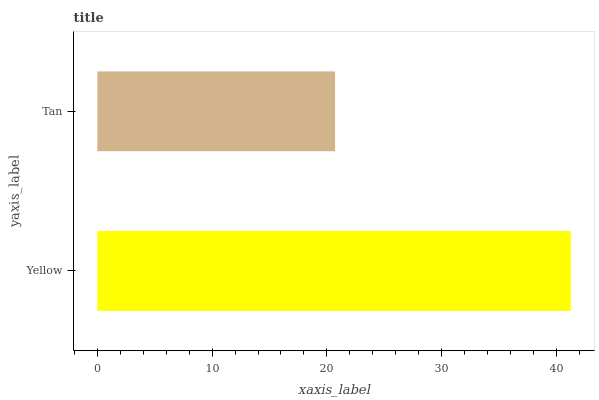Is Tan the minimum?
Answer yes or no. Yes. Is Yellow the maximum?
Answer yes or no. Yes. Is Tan the maximum?
Answer yes or no. No. Is Yellow greater than Tan?
Answer yes or no. Yes. Is Tan less than Yellow?
Answer yes or no. Yes. Is Tan greater than Yellow?
Answer yes or no. No. Is Yellow less than Tan?
Answer yes or no. No. Is Yellow the high median?
Answer yes or no. Yes. Is Tan the low median?
Answer yes or no. Yes. Is Tan the high median?
Answer yes or no. No. Is Yellow the low median?
Answer yes or no. No. 